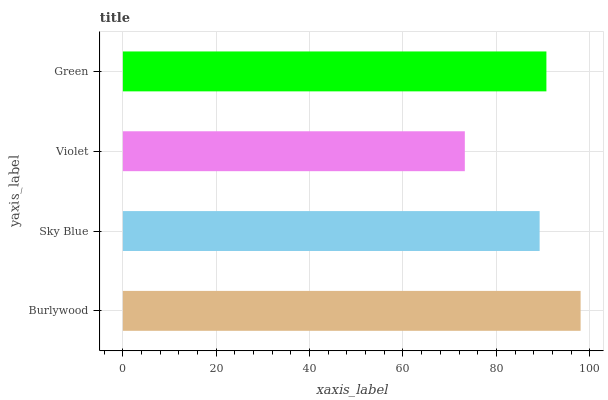Is Violet the minimum?
Answer yes or no. Yes. Is Burlywood the maximum?
Answer yes or no. Yes. Is Sky Blue the minimum?
Answer yes or no. No. Is Sky Blue the maximum?
Answer yes or no. No. Is Burlywood greater than Sky Blue?
Answer yes or no. Yes. Is Sky Blue less than Burlywood?
Answer yes or no. Yes. Is Sky Blue greater than Burlywood?
Answer yes or no. No. Is Burlywood less than Sky Blue?
Answer yes or no. No. Is Green the high median?
Answer yes or no. Yes. Is Sky Blue the low median?
Answer yes or no. Yes. Is Sky Blue the high median?
Answer yes or no. No. Is Green the low median?
Answer yes or no. No. 